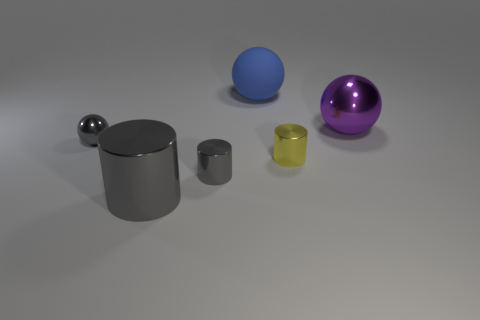Are there any tiny metal objects in front of the gray metal ball?
Give a very brief answer. Yes. There is a large thing that is on the left side of the big blue thing; what color is it?
Provide a succinct answer. Gray. What is the material of the tiny gray object that is in front of the metallic ball that is left of the blue rubber thing?
Give a very brief answer. Metal. Are there fewer blue objects that are in front of the large blue rubber object than yellow metallic things in front of the small gray sphere?
Make the answer very short. Yes. What number of blue objects are either big metallic balls or cylinders?
Keep it short and to the point. 0. Are there an equal number of tiny yellow things to the right of the yellow metal object and purple rubber cylinders?
Provide a short and direct response. Yes. What number of things are small yellow cylinders or big spheres that are behind the large purple shiny ball?
Ensure brevity in your answer.  2. Is the color of the small ball the same as the large metal cylinder?
Keep it short and to the point. Yes. Is there a large thing made of the same material as the large cylinder?
Provide a short and direct response. Yes. What color is the large metallic thing that is the same shape as the large blue rubber thing?
Your answer should be very brief. Purple. 